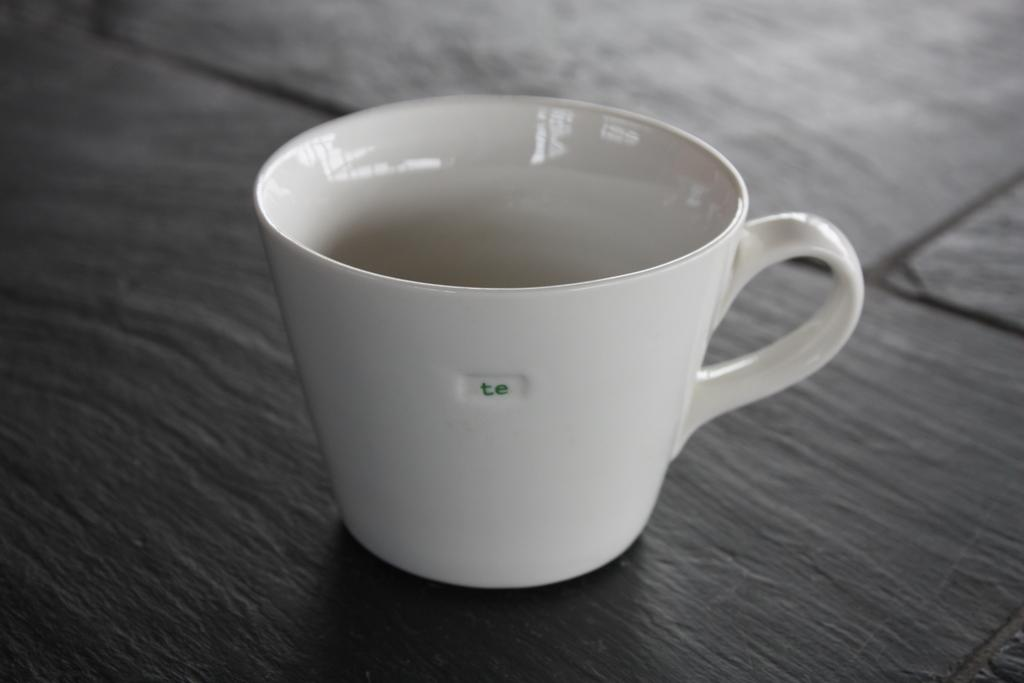What color is the cup in the image? The cup in the image is white in color. Where is the cup located in the image? The cup is placed on a table. What is the color of the table in the image? The table in the image is black in color. What advertisement is displayed on the cup in the image? There is no advertisement displayed on the cup in the image; it is a plain white cup. How many slaves are visible in the image? There are no slaves present in the image. 